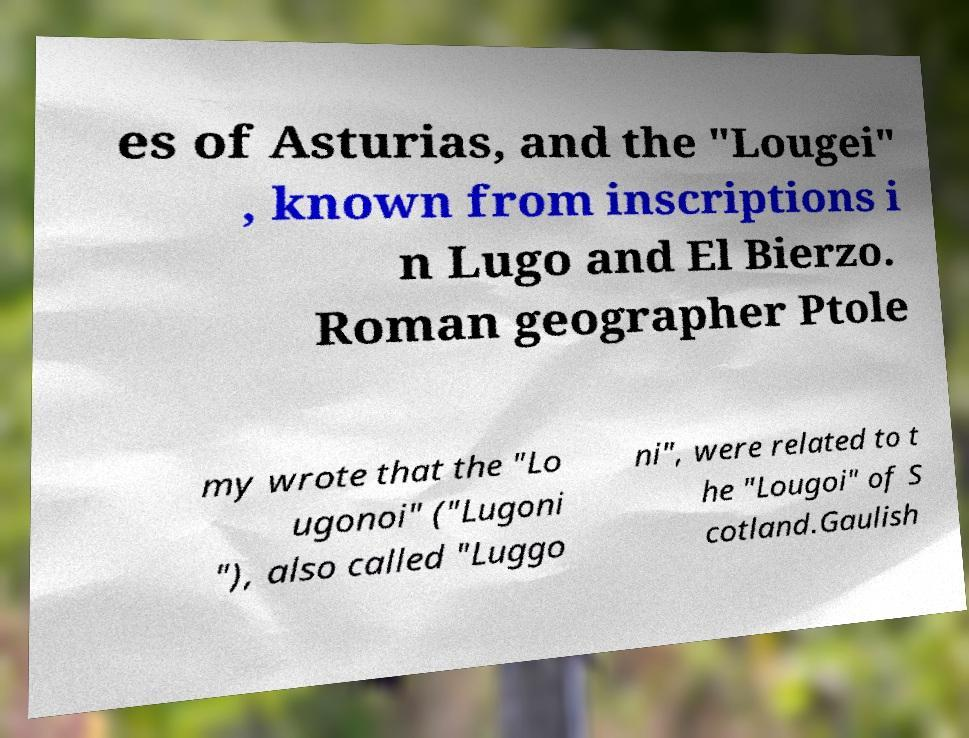I need the written content from this picture converted into text. Can you do that? es of Asturias, and the "Lougei" , known from inscriptions i n Lugo and El Bierzo. Roman geographer Ptole my wrote that the "Lo ugonoi" ("Lugoni "), also called "Luggo ni", were related to t he "Lougoi" of S cotland.Gaulish 